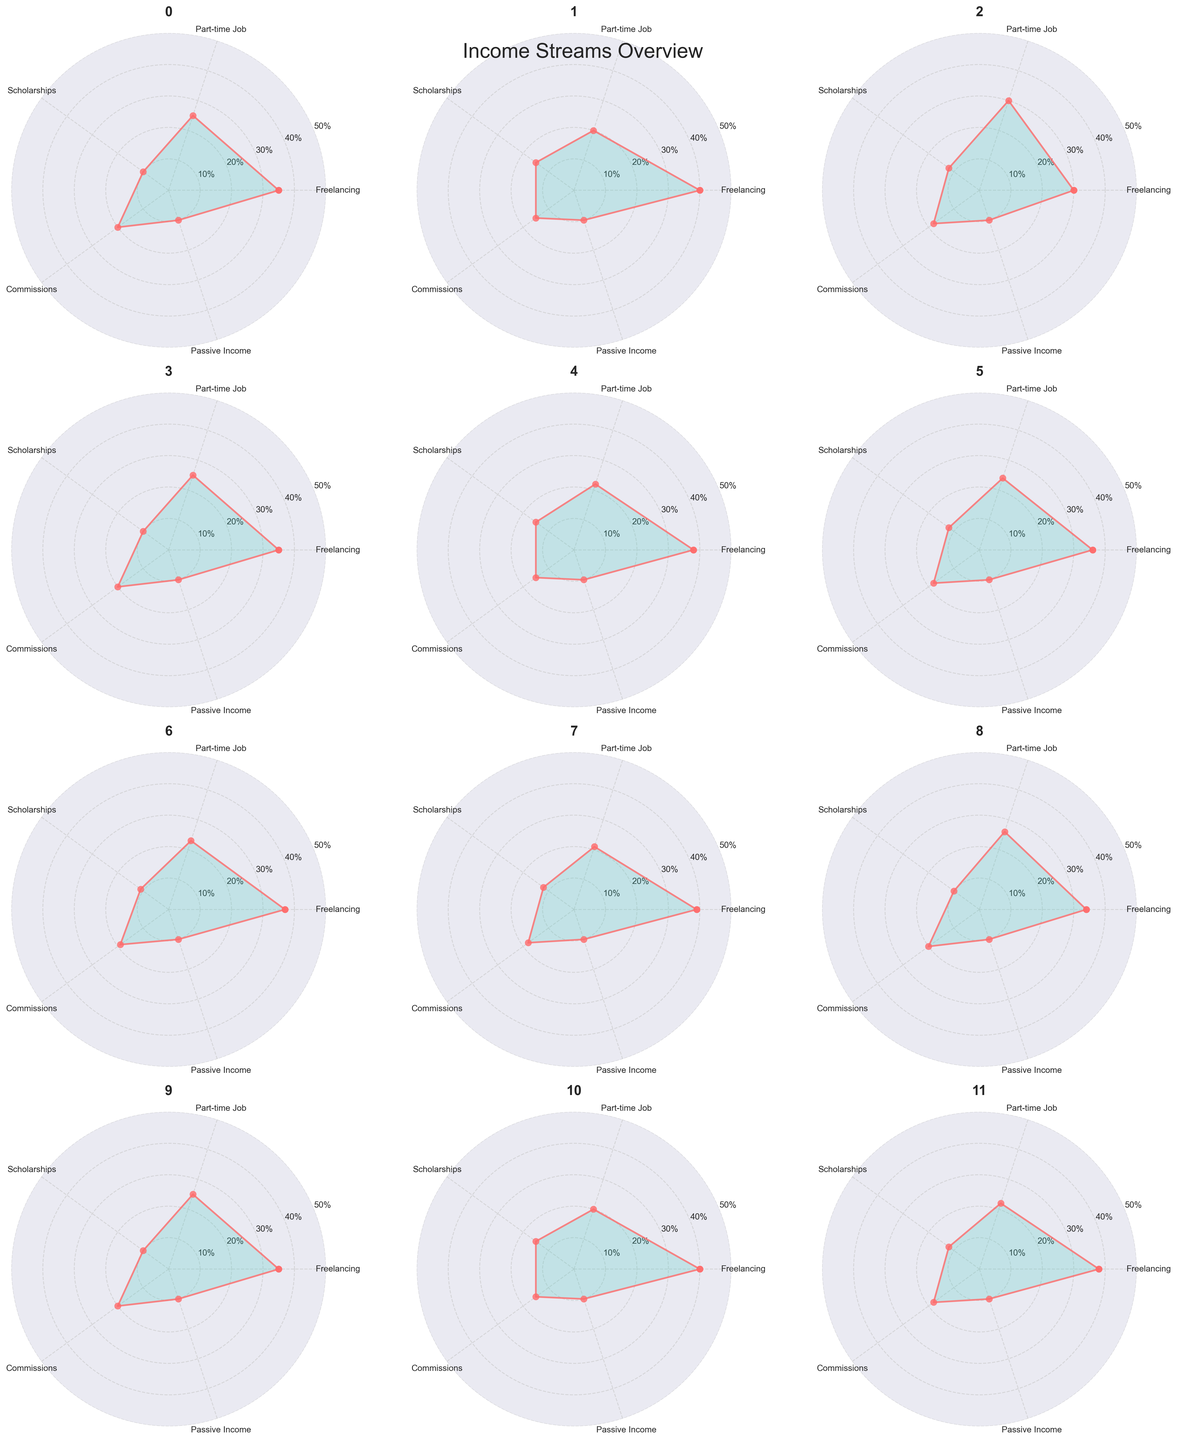What month has the highest percentage of income from freelancing? By looking at each subplot, identify which month has the highest value on the Freelancing axis. February and November both have the highest value of 40%.
Answer: February and November What is the range of percentages for part-time jobs across the months? Identify the minimum and maximum values on the Part-time Job axis among all the subplots. The minimum is 20% (February, November), and the maximum is 30% (March). The range is 30% - 20% = 10%.
Answer: 10% On average, what percentage of income comes from scholarships throughout the year? Add the Scholarship percentages for each month: (10+15+12+10+15+12+11+12+10+10+15+12) = 144%. Divide by the number of months: 144% / 12 months ≈ 12%.
Answer: 12% In which months do commissions contribute equally to the overall income (all months with the same value)? Find the months where the values on the Commissions axis are the same. There are five months where commissions contribute 20%: January, April, September, October, and five months where it contributes 18%: March, June, July, August, and December.
Answer: January, April, September, October and March, June, July, August, December What is the predominant income source for March? In the March subplot, the value on the Part-time Job axis is highest (30%) compared to other sources.
Answer: Part-time Job Which month has the least variability in income sources? Calculate the range (difference between max and min values) for each month and compare. January, April, September, and October have the same percentage differences (25% - 10% = 15%).
Answer: January, April, September, October Are there any months where passive income percentages vary? Check the Passive Income axis across all subplots. All months have 10% for passive income.
Answer: No Between June and July, which month has a higher percentage of income from commissions? Compare the values on the Commissions axis for June and July. June has 18%, while July has 19%.
Answer: July Which month sees the highest income from freelancing after February and November? Identify the highest Freelancing percentage excluding February and November. The next highest is 39% in August.
Answer: August What is the median percentage of income from commissions across all months? List the Commission percentages in ascending order: 15, 15, 15, 15, 18, 18, 18, 18, 19, 20, 20, 20. The median value is the average of the 6th and 7th values: (18% + 18%) / 2 = 18%.
Answer: 18% 